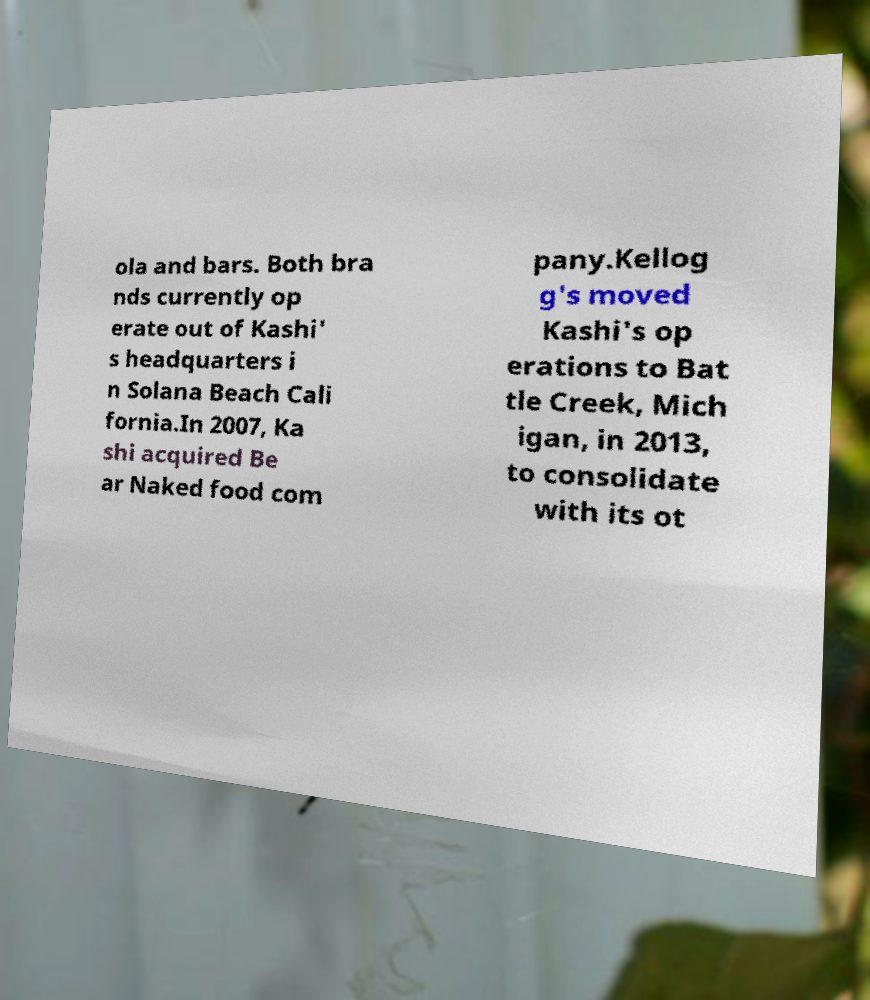For documentation purposes, I need the text within this image transcribed. Could you provide that? ola and bars. Both bra nds currently op erate out of Kashi' s headquarters i n Solana Beach Cali fornia.In 2007, Ka shi acquired Be ar Naked food com pany.Kellog g's moved Kashi's op erations to Bat tle Creek, Mich igan, in 2013, to consolidate with its ot 